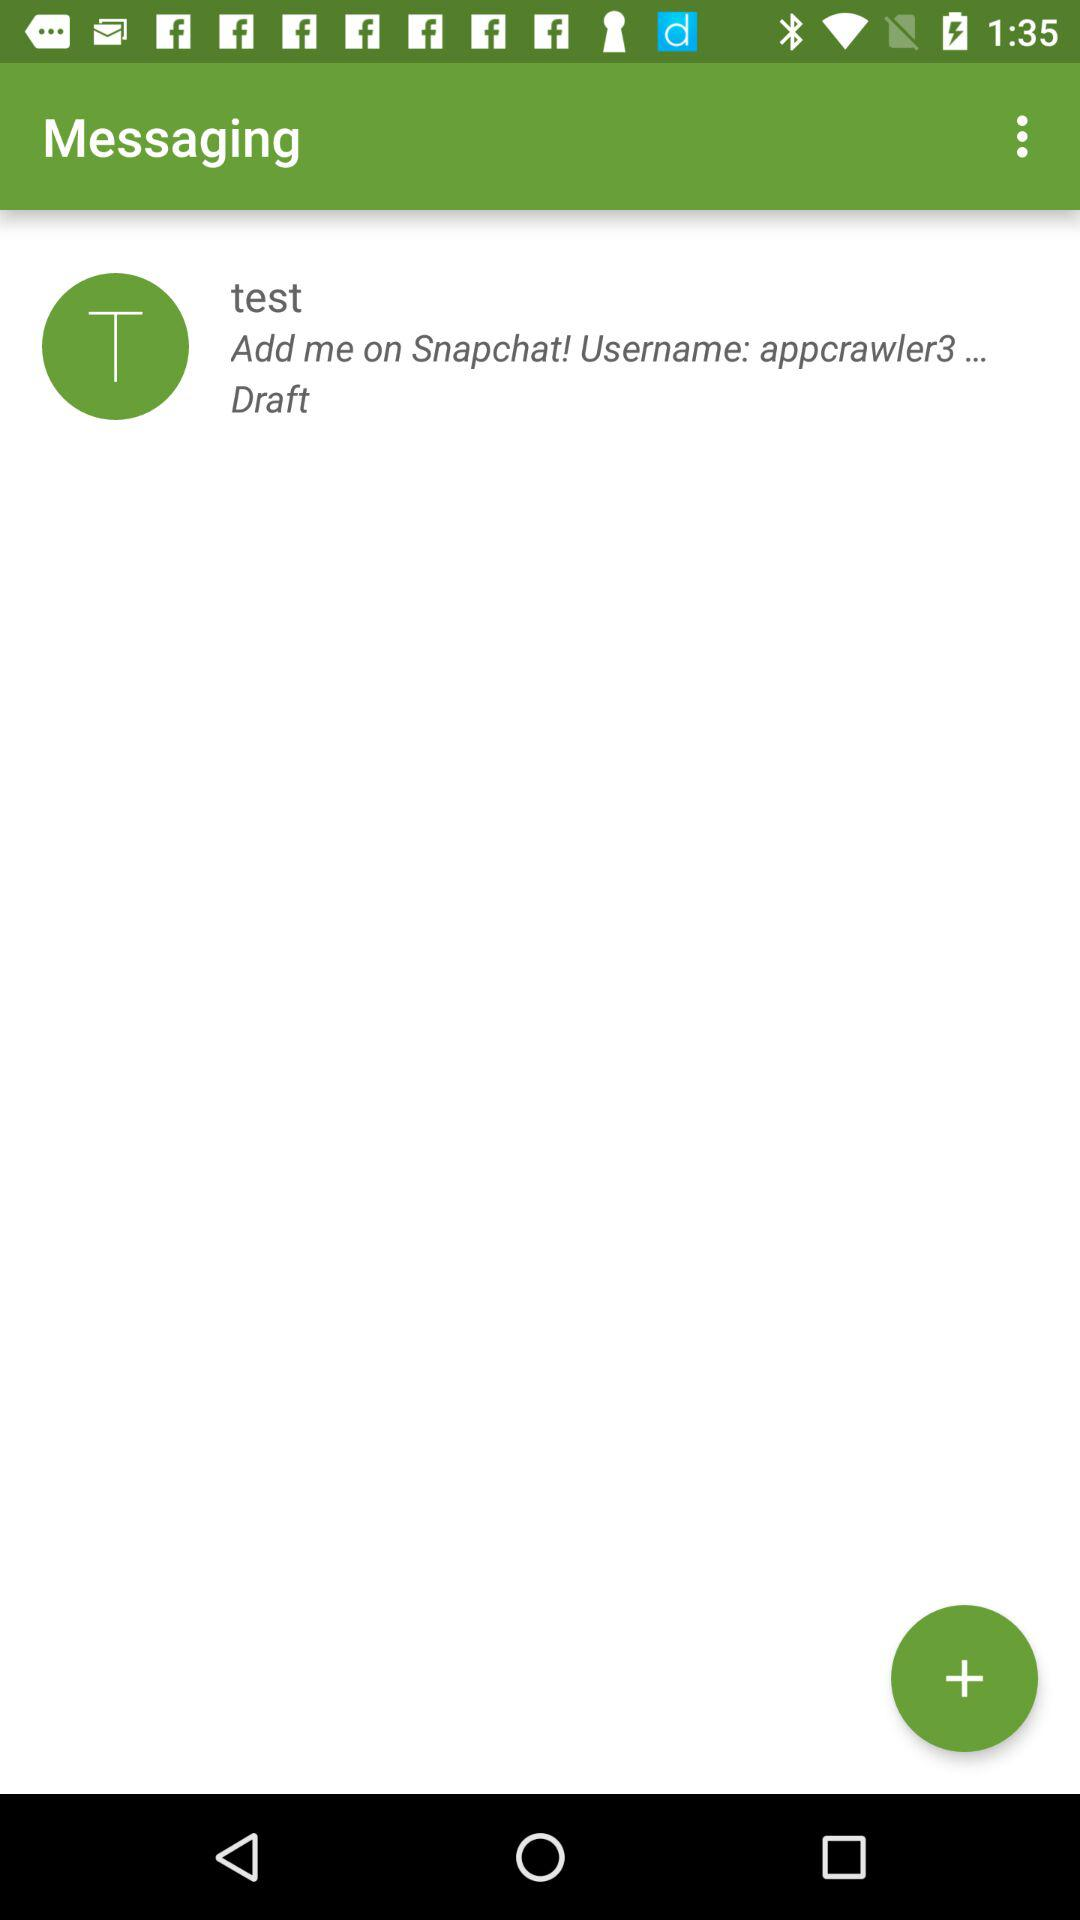What is the mentioned username? The mentioned usernames are "test" and "appcrawler3". 